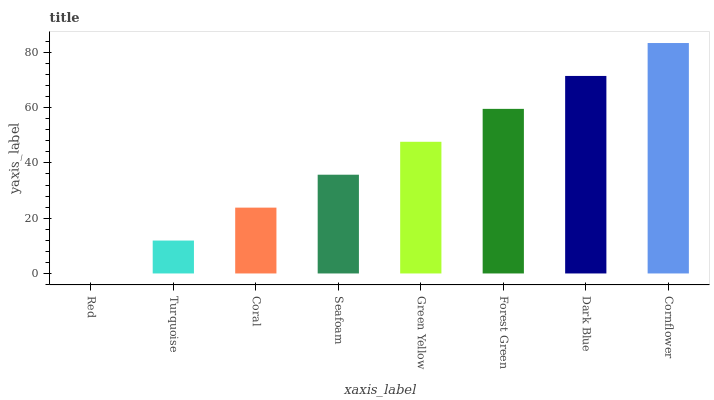Is Red the minimum?
Answer yes or no. Yes. Is Cornflower the maximum?
Answer yes or no. Yes. Is Turquoise the minimum?
Answer yes or no. No. Is Turquoise the maximum?
Answer yes or no. No. Is Turquoise greater than Red?
Answer yes or no. Yes. Is Red less than Turquoise?
Answer yes or no. Yes. Is Red greater than Turquoise?
Answer yes or no. No. Is Turquoise less than Red?
Answer yes or no. No. Is Green Yellow the high median?
Answer yes or no. Yes. Is Seafoam the low median?
Answer yes or no. Yes. Is Coral the high median?
Answer yes or no. No. Is Coral the low median?
Answer yes or no. No. 